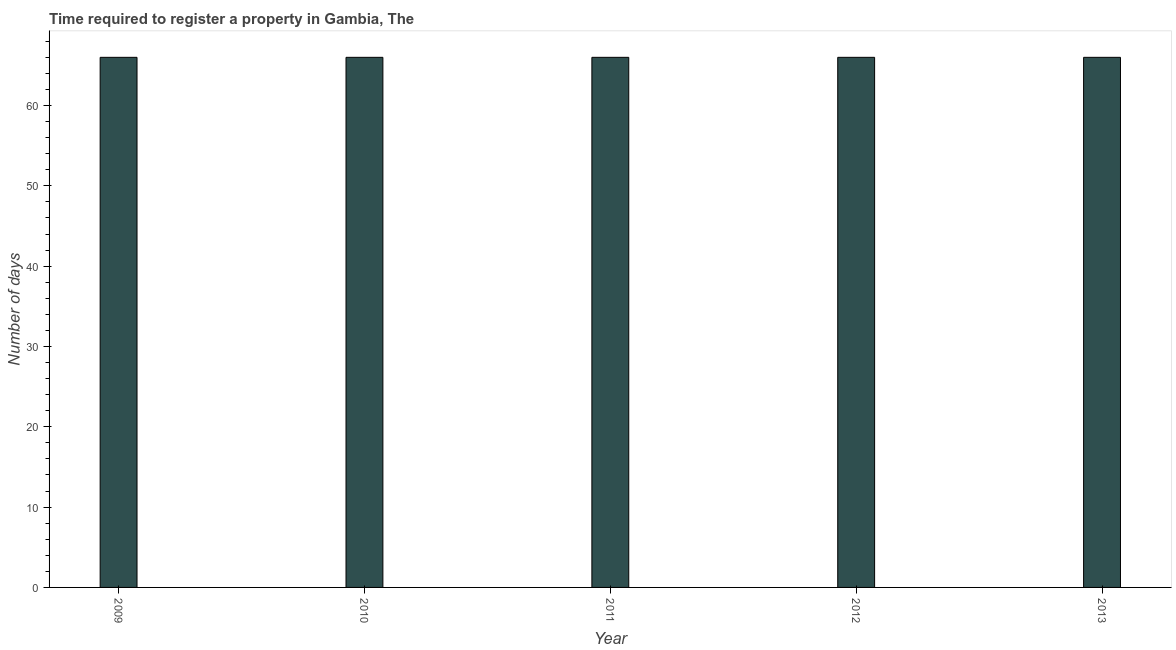Does the graph contain grids?
Provide a succinct answer. No. What is the title of the graph?
Make the answer very short. Time required to register a property in Gambia, The. What is the label or title of the X-axis?
Make the answer very short. Year. What is the label or title of the Y-axis?
Give a very brief answer. Number of days. What is the number of days required to register property in 2011?
Your response must be concise. 66. Across all years, what is the minimum number of days required to register property?
Keep it short and to the point. 66. In which year was the number of days required to register property minimum?
Your answer should be compact. 2009. What is the sum of the number of days required to register property?
Your answer should be very brief. 330. What is the difference between the number of days required to register property in 2011 and 2012?
Offer a terse response. 0. What is the average number of days required to register property per year?
Provide a succinct answer. 66. In how many years, is the number of days required to register property greater than 66 days?
Offer a terse response. 0. What is the ratio of the number of days required to register property in 2011 to that in 2012?
Provide a succinct answer. 1. Is the number of days required to register property in 2009 less than that in 2013?
Offer a very short reply. No. In how many years, is the number of days required to register property greater than the average number of days required to register property taken over all years?
Your answer should be compact. 0. How many bars are there?
Keep it short and to the point. 5. Are all the bars in the graph horizontal?
Keep it short and to the point. No. How many years are there in the graph?
Your answer should be very brief. 5. Are the values on the major ticks of Y-axis written in scientific E-notation?
Provide a succinct answer. No. What is the Number of days of 2010?
Make the answer very short. 66. What is the difference between the Number of days in 2009 and 2010?
Offer a very short reply. 0. What is the difference between the Number of days in 2010 and 2012?
Keep it short and to the point. 0. What is the difference between the Number of days in 2011 and 2013?
Your answer should be very brief. 0. What is the ratio of the Number of days in 2009 to that in 2010?
Offer a very short reply. 1. What is the ratio of the Number of days in 2009 to that in 2011?
Make the answer very short. 1. What is the ratio of the Number of days in 2009 to that in 2013?
Provide a short and direct response. 1. What is the ratio of the Number of days in 2011 to that in 2012?
Offer a terse response. 1. What is the ratio of the Number of days in 2011 to that in 2013?
Make the answer very short. 1. What is the ratio of the Number of days in 2012 to that in 2013?
Provide a short and direct response. 1. 